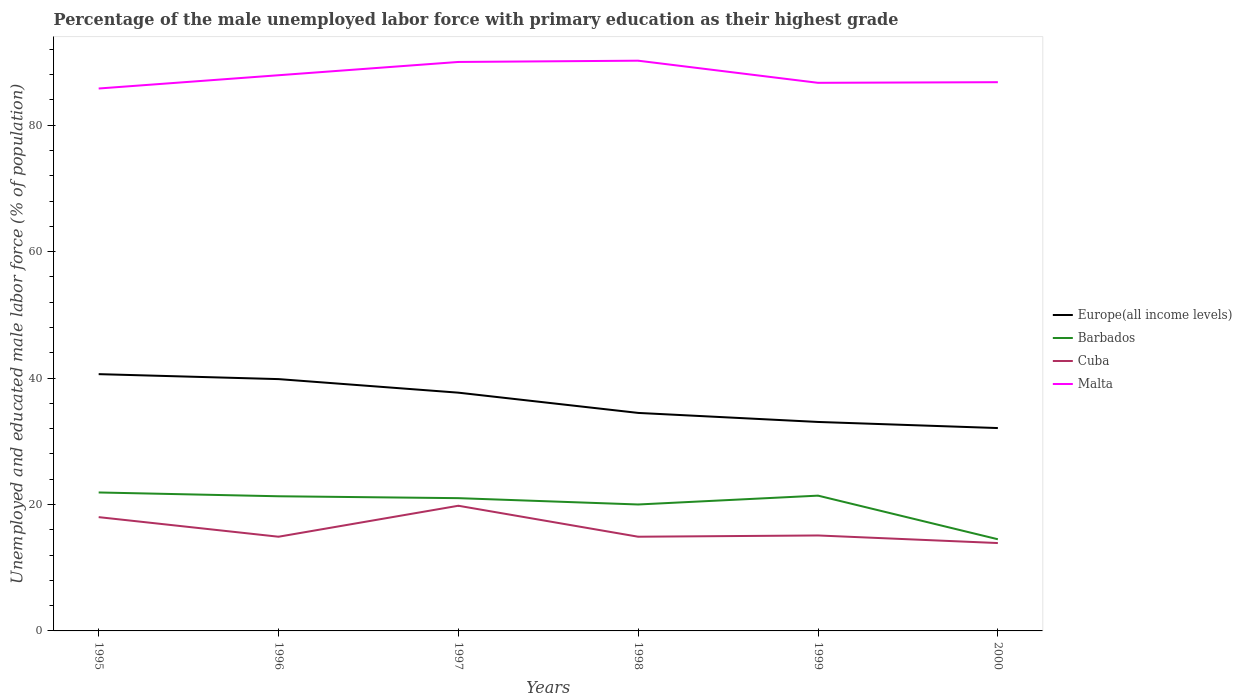How many different coloured lines are there?
Your response must be concise. 4. Is the number of lines equal to the number of legend labels?
Your response must be concise. Yes. Across all years, what is the maximum percentage of the unemployed male labor force with primary education in Cuba?
Your response must be concise. 13.9. In which year was the percentage of the unemployed male labor force with primary education in Europe(all income levels) maximum?
Offer a very short reply. 2000. What is the total percentage of the unemployed male labor force with primary education in Europe(all income levels) in the graph?
Provide a short and direct response. 4.63. What is the difference between the highest and the second highest percentage of the unemployed male labor force with primary education in Barbados?
Keep it short and to the point. 7.4. How many years are there in the graph?
Provide a short and direct response. 6. Are the values on the major ticks of Y-axis written in scientific E-notation?
Offer a terse response. No. Where does the legend appear in the graph?
Make the answer very short. Center right. How are the legend labels stacked?
Offer a very short reply. Vertical. What is the title of the graph?
Offer a terse response. Percentage of the male unemployed labor force with primary education as their highest grade. What is the label or title of the Y-axis?
Provide a short and direct response. Unemployed and educated male labor force (% of population). What is the Unemployed and educated male labor force (% of population) of Europe(all income levels) in 1995?
Keep it short and to the point. 40.62. What is the Unemployed and educated male labor force (% of population) of Barbados in 1995?
Offer a terse response. 21.9. What is the Unemployed and educated male labor force (% of population) in Malta in 1995?
Keep it short and to the point. 85.8. What is the Unemployed and educated male labor force (% of population) in Europe(all income levels) in 1996?
Keep it short and to the point. 39.83. What is the Unemployed and educated male labor force (% of population) in Barbados in 1996?
Offer a very short reply. 21.3. What is the Unemployed and educated male labor force (% of population) of Cuba in 1996?
Make the answer very short. 14.9. What is the Unemployed and educated male labor force (% of population) in Malta in 1996?
Your answer should be very brief. 87.9. What is the Unemployed and educated male labor force (% of population) of Europe(all income levels) in 1997?
Provide a succinct answer. 37.69. What is the Unemployed and educated male labor force (% of population) of Cuba in 1997?
Give a very brief answer. 19.8. What is the Unemployed and educated male labor force (% of population) in Malta in 1997?
Offer a terse response. 90. What is the Unemployed and educated male labor force (% of population) in Europe(all income levels) in 1998?
Provide a short and direct response. 34.48. What is the Unemployed and educated male labor force (% of population) in Barbados in 1998?
Keep it short and to the point. 20. What is the Unemployed and educated male labor force (% of population) in Cuba in 1998?
Offer a very short reply. 14.9. What is the Unemployed and educated male labor force (% of population) of Malta in 1998?
Keep it short and to the point. 90.2. What is the Unemployed and educated male labor force (% of population) in Europe(all income levels) in 1999?
Provide a succinct answer. 33.05. What is the Unemployed and educated male labor force (% of population) of Barbados in 1999?
Your answer should be compact. 21.4. What is the Unemployed and educated male labor force (% of population) in Cuba in 1999?
Your response must be concise. 15.1. What is the Unemployed and educated male labor force (% of population) in Malta in 1999?
Keep it short and to the point. 86.7. What is the Unemployed and educated male labor force (% of population) of Europe(all income levels) in 2000?
Make the answer very short. 32.09. What is the Unemployed and educated male labor force (% of population) in Barbados in 2000?
Keep it short and to the point. 14.5. What is the Unemployed and educated male labor force (% of population) of Cuba in 2000?
Your answer should be compact. 13.9. What is the Unemployed and educated male labor force (% of population) in Malta in 2000?
Provide a short and direct response. 86.8. Across all years, what is the maximum Unemployed and educated male labor force (% of population) in Europe(all income levels)?
Ensure brevity in your answer.  40.62. Across all years, what is the maximum Unemployed and educated male labor force (% of population) of Barbados?
Your response must be concise. 21.9. Across all years, what is the maximum Unemployed and educated male labor force (% of population) of Cuba?
Keep it short and to the point. 19.8. Across all years, what is the maximum Unemployed and educated male labor force (% of population) in Malta?
Ensure brevity in your answer.  90.2. Across all years, what is the minimum Unemployed and educated male labor force (% of population) of Europe(all income levels)?
Your answer should be compact. 32.09. Across all years, what is the minimum Unemployed and educated male labor force (% of population) of Barbados?
Offer a very short reply. 14.5. Across all years, what is the minimum Unemployed and educated male labor force (% of population) of Cuba?
Offer a terse response. 13.9. Across all years, what is the minimum Unemployed and educated male labor force (% of population) in Malta?
Ensure brevity in your answer.  85.8. What is the total Unemployed and educated male labor force (% of population) in Europe(all income levels) in the graph?
Offer a terse response. 217.77. What is the total Unemployed and educated male labor force (% of population) of Barbados in the graph?
Give a very brief answer. 120.1. What is the total Unemployed and educated male labor force (% of population) of Cuba in the graph?
Provide a short and direct response. 96.6. What is the total Unemployed and educated male labor force (% of population) of Malta in the graph?
Your answer should be compact. 527.4. What is the difference between the Unemployed and educated male labor force (% of population) in Europe(all income levels) in 1995 and that in 1996?
Ensure brevity in your answer.  0.78. What is the difference between the Unemployed and educated male labor force (% of population) of Barbados in 1995 and that in 1996?
Your response must be concise. 0.6. What is the difference between the Unemployed and educated male labor force (% of population) in Malta in 1995 and that in 1996?
Your answer should be compact. -2.1. What is the difference between the Unemployed and educated male labor force (% of population) of Europe(all income levels) in 1995 and that in 1997?
Provide a short and direct response. 2.93. What is the difference between the Unemployed and educated male labor force (% of population) of Barbados in 1995 and that in 1997?
Your answer should be compact. 0.9. What is the difference between the Unemployed and educated male labor force (% of population) in Cuba in 1995 and that in 1997?
Your answer should be compact. -1.8. What is the difference between the Unemployed and educated male labor force (% of population) of Europe(all income levels) in 1995 and that in 1998?
Keep it short and to the point. 6.13. What is the difference between the Unemployed and educated male labor force (% of population) of Barbados in 1995 and that in 1998?
Your answer should be compact. 1.9. What is the difference between the Unemployed and educated male labor force (% of population) of Europe(all income levels) in 1995 and that in 1999?
Ensure brevity in your answer.  7.56. What is the difference between the Unemployed and educated male labor force (% of population) of Barbados in 1995 and that in 1999?
Offer a terse response. 0.5. What is the difference between the Unemployed and educated male labor force (% of population) of Cuba in 1995 and that in 1999?
Provide a short and direct response. 2.9. What is the difference between the Unemployed and educated male labor force (% of population) of Malta in 1995 and that in 1999?
Your response must be concise. -0.9. What is the difference between the Unemployed and educated male labor force (% of population) of Europe(all income levels) in 1995 and that in 2000?
Provide a short and direct response. 8.53. What is the difference between the Unemployed and educated male labor force (% of population) of Cuba in 1995 and that in 2000?
Your answer should be compact. 4.1. What is the difference between the Unemployed and educated male labor force (% of population) of Europe(all income levels) in 1996 and that in 1997?
Your answer should be compact. 2.14. What is the difference between the Unemployed and educated male labor force (% of population) of Europe(all income levels) in 1996 and that in 1998?
Ensure brevity in your answer.  5.35. What is the difference between the Unemployed and educated male labor force (% of population) of Cuba in 1996 and that in 1998?
Ensure brevity in your answer.  0. What is the difference between the Unemployed and educated male labor force (% of population) of Malta in 1996 and that in 1998?
Your response must be concise. -2.3. What is the difference between the Unemployed and educated male labor force (% of population) in Europe(all income levels) in 1996 and that in 1999?
Give a very brief answer. 6.78. What is the difference between the Unemployed and educated male labor force (% of population) of Barbados in 1996 and that in 1999?
Your response must be concise. -0.1. What is the difference between the Unemployed and educated male labor force (% of population) in Europe(all income levels) in 1996 and that in 2000?
Make the answer very short. 7.74. What is the difference between the Unemployed and educated male labor force (% of population) of Cuba in 1996 and that in 2000?
Provide a short and direct response. 1. What is the difference between the Unemployed and educated male labor force (% of population) in Malta in 1996 and that in 2000?
Offer a terse response. 1.1. What is the difference between the Unemployed and educated male labor force (% of population) of Europe(all income levels) in 1997 and that in 1998?
Your answer should be very brief. 3.2. What is the difference between the Unemployed and educated male labor force (% of population) of Europe(all income levels) in 1997 and that in 1999?
Offer a very short reply. 4.63. What is the difference between the Unemployed and educated male labor force (% of population) of Cuba in 1997 and that in 1999?
Offer a terse response. 4.7. What is the difference between the Unemployed and educated male labor force (% of population) of Europe(all income levels) in 1997 and that in 2000?
Make the answer very short. 5.6. What is the difference between the Unemployed and educated male labor force (% of population) of Barbados in 1997 and that in 2000?
Your response must be concise. 6.5. What is the difference between the Unemployed and educated male labor force (% of population) in Cuba in 1997 and that in 2000?
Your answer should be compact. 5.9. What is the difference between the Unemployed and educated male labor force (% of population) in Malta in 1997 and that in 2000?
Give a very brief answer. 3.2. What is the difference between the Unemployed and educated male labor force (% of population) in Europe(all income levels) in 1998 and that in 1999?
Your answer should be compact. 1.43. What is the difference between the Unemployed and educated male labor force (% of population) in Cuba in 1998 and that in 1999?
Offer a terse response. -0.2. What is the difference between the Unemployed and educated male labor force (% of population) of Europe(all income levels) in 1998 and that in 2000?
Your response must be concise. 2.4. What is the difference between the Unemployed and educated male labor force (% of population) in Malta in 1998 and that in 2000?
Offer a terse response. 3.4. What is the difference between the Unemployed and educated male labor force (% of population) in Europe(all income levels) in 1999 and that in 2000?
Your response must be concise. 0.97. What is the difference between the Unemployed and educated male labor force (% of population) of Cuba in 1999 and that in 2000?
Your answer should be compact. 1.2. What is the difference between the Unemployed and educated male labor force (% of population) of Malta in 1999 and that in 2000?
Provide a succinct answer. -0.1. What is the difference between the Unemployed and educated male labor force (% of population) in Europe(all income levels) in 1995 and the Unemployed and educated male labor force (% of population) in Barbados in 1996?
Make the answer very short. 19.32. What is the difference between the Unemployed and educated male labor force (% of population) in Europe(all income levels) in 1995 and the Unemployed and educated male labor force (% of population) in Cuba in 1996?
Your answer should be very brief. 25.72. What is the difference between the Unemployed and educated male labor force (% of population) of Europe(all income levels) in 1995 and the Unemployed and educated male labor force (% of population) of Malta in 1996?
Ensure brevity in your answer.  -47.28. What is the difference between the Unemployed and educated male labor force (% of population) of Barbados in 1995 and the Unemployed and educated male labor force (% of population) of Cuba in 1996?
Give a very brief answer. 7. What is the difference between the Unemployed and educated male labor force (% of population) of Barbados in 1995 and the Unemployed and educated male labor force (% of population) of Malta in 1996?
Your response must be concise. -66. What is the difference between the Unemployed and educated male labor force (% of population) in Cuba in 1995 and the Unemployed and educated male labor force (% of population) in Malta in 1996?
Keep it short and to the point. -69.9. What is the difference between the Unemployed and educated male labor force (% of population) in Europe(all income levels) in 1995 and the Unemployed and educated male labor force (% of population) in Barbados in 1997?
Ensure brevity in your answer.  19.62. What is the difference between the Unemployed and educated male labor force (% of population) of Europe(all income levels) in 1995 and the Unemployed and educated male labor force (% of population) of Cuba in 1997?
Ensure brevity in your answer.  20.82. What is the difference between the Unemployed and educated male labor force (% of population) in Europe(all income levels) in 1995 and the Unemployed and educated male labor force (% of population) in Malta in 1997?
Your response must be concise. -49.38. What is the difference between the Unemployed and educated male labor force (% of population) in Barbados in 1995 and the Unemployed and educated male labor force (% of population) in Malta in 1997?
Offer a very short reply. -68.1. What is the difference between the Unemployed and educated male labor force (% of population) of Cuba in 1995 and the Unemployed and educated male labor force (% of population) of Malta in 1997?
Make the answer very short. -72. What is the difference between the Unemployed and educated male labor force (% of population) of Europe(all income levels) in 1995 and the Unemployed and educated male labor force (% of population) of Barbados in 1998?
Give a very brief answer. 20.62. What is the difference between the Unemployed and educated male labor force (% of population) in Europe(all income levels) in 1995 and the Unemployed and educated male labor force (% of population) in Cuba in 1998?
Keep it short and to the point. 25.72. What is the difference between the Unemployed and educated male labor force (% of population) in Europe(all income levels) in 1995 and the Unemployed and educated male labor force (% of population) in Malta in 1998?
Make the answer very short. -49.58. What is the difference between the Unemployed and educated male labor force (% of population) in Barbados in 1995 and the Unemployed and educated male labor force (% of population) in Cuba in 1998?
Provide a short and direct response. 7. What is the difference between the Unemployed and educated male labor force (% of population) of Barbados in 1995 and the Unemployed and educated male labor force (% of population) of Malta in 1998?
Provide a succinct answer. -68.3. What is the difference between the Unemployed and educated male labor force (% of population) of Cuba in 1995 and the Unemployed and educated male labor force (% of population) of Malta in 1998?
Your answer should be very brief. -72.2. What is the difference between the Unemployed and educated male labor force (% of population) of Europe(all income levels) in 1995 and the Unemployed and educated male labor force (% of population) of Barbados in 1999?
Give a very brief answer. 19.22. What is the difference between the Unemployed and educated male labor force (% of population) of Europe(all income levels) in 1995 and the Unemployed and educated male labor force (% of population) of Cuba in 1999?
Offer a terse response. 25.52. What is the difference between the Unemployed and educated male labor force (% of population) of Europe(all income levels) in 1995 and the Unemployed and educated male labor force (% of population) of Malta in 1999?
Offer a very short reply. -46.08. What is the difference between the Unemployed and educated male labor force (% of population) of Barbados in 1995 and the Unemployed and educated male labor force (% of population) of Malta in 1999?
Your answer should be very brief. -64.8. What is the difference between the Unemployed and educated male labor force (% of population) of Cuba in 1995 and the Unemployed and educated male labor force (% of population) of Malta in 1999?
Offer a terse response. -68.7. What is the difference between the Unemployed and educated male labor force (% of population) in Europe(all income levels) in 1995 and the Unemployed and educated male labor force (% of population) in Barbados in 2000?
Keep it short and to the point. 26.12. What is the difference between the Unemployed and educated male labor force (% of population) of Europe(all income levels) in 1995 and the Unemployed and educated male labor force (% of population) of Cuba in 2000?
Your answer should be compact. 26.72. What is the difference between the Unemployed and educated male labor force (% of population) in Europe(all income levels) in 1995 and the Unemployed and educated male labor force (% of population) in Malta in 2000?
Your answer should be compact. -46.18. What is the difference between the Unemployed and educated male labor force (% of population) of Barbados in 1995 and the Unemployed and educated male labor force (% of population) of Malta in 2000?
Give a very brief answer. -64.9. What is the difference between the Unemployed and educated male labor force (% of population) in Cuba in 1995 and the Unemployed and educated male labor force (% of population) in Malta in 2000?
Your response must be concise. -68.8. What is the difference between the Unemployed and educated male labor force (% of population) in Europe(all income levels) in 1996 and the Unemployed and educated male labor force (% of population) in Barbados in 1997?
Your response must be concise. 18.83. What is the difference between the Unemployed and educated male labor force (% of population) in Europe(all income levels) in 1996 and the Unemployed and educated male labor force (% of population) in Cuba in 1997?
Keep it short and to the point. 20.03. What is the difference between the Unemployed and educated male labor force (% of population) of Europe(all income levels) in 1996 and the Unemployed and educated male labor force (% of population) of Malta in 1997?
Ensure brevity in your answer.  -50.17. What is the difference between the Unemployed and educated male labor force (% of population) in Barbados in 1996 and the Unemployed and educated male labor force (% of population) in Cuba in 1997?
Provide a short and direct response. 1.5. What is the difference between the Unemployed and educated male labor force (% of population) of Barbados in 1996 and the Unemployed and educated male labor force (% of population) of Malta in 1997?
Offer a terse response. -68.7. What is the difference between the Unemployed and educated male labor force (% of population) in Cuba in 1996 and the Unemployed and educated male labor force (% of population) in Malta in 1997?
Offer a terse response. -75.1. What is the difference between the Unemployed and educated male labor force (% of population) in Europe(all income levels) in 1996 and the Unemployed and educated male labor force (% of population) in Barbados in 1998?
Offer a terse response. 19.83. What is the difference between the Unemployed and educated male labor force (% of population) of Europe(all income levels) in 1996 and the Unemployed and educated male labor force (% of population) of Cuba in 1998?
Provide a short and direct response. 24.93. What is the difference between the Unemployed and educated male labor force (% of population) of Europe(all income levels) in 1996 and the Unemployed and educated male labor force (% of population) of Malta in 1998?
Provide a short and direct response. -50.37. What is the difference between the Unemployed and educated male labor force (% of population) of Barbados in 1996 and the Unemployed and educated male labor force (% of population) of Malta in 1998?
Offer a very short reply. -68.9. What is the difference between the Unemployed and educated male labor force (% of population) in Cuba in 1996 and the Unemployed and educated male labor force (% of population) in Malta in 1998?
Ensure brevity in your answer.  -75.3. What is the difference between the Unemployed and educated male labor force (% of population) of Europe(all income levels) in 1996 and the Unemployed and educated male labor force (% of population) of Barbados in 1999?
Your answer should be compact. 18.43. What is the difference between the Unemployed and educated male labor force (% of population) of Europe(all income levels) in 1996 and the Unemployed and educated male labor force (% of population) of Cuba in 1999?
Ensure brevity in your answer.  24.73. What is the difference between the Unemployed and educated male labor force (% of population) of Europe(all income levels) in 1996 and the Unemployed and educated male labor force (% of population) of Malta in 1999?
Provide a succinct answer. -46.87. What is the difference between the Unemployed and educated male labor force (% of population) in Barbados in 1996 and the Unemployed and educated male labor force (% of population) in Malta in 1999?
Ensure brevity in your answer.  -65.4. What is the difference between the Unemployed and educated male labor force (% of population) in Cuba in 1996 and the Unemployed and educated male labor force (% of population) in Malta in 1999?
Give a very brief answer. -71.8. What is the difference between the Unemployed and educated male labor force (% of population) in Europe(all income levels) in 1996 and the Unemployed and educated male labor force (% of population) in Barbados in 2000?
Offer a terse response. 25.33. What is the difference between the Unemployed and educated male labor force (% of population) of Europe(all income levels) in 1996 and the Unemployed and educated male labor force (% of population) of Cuba in 2000?
Provide a short and direct response. 25.93. What is the difference between the Unemployed and educated male labor force (% of population) in Europe(all income levels) in 1996 and the Unemployed and educated male labor force (% of population) in Malta in 2000?
Ensure brevity in your answer.  -46.97. What is the difference between the Unemployed and educated male labor force (% of population) of Barbados in 1996 and the Unemployed and educated male labor force (% of population) of Malta in 2000?
Offer a very short reply. -65.5. What is the difference between the Unemployed and educated male labor force (% of population) of Cuba in 1996 and the Unemployed and educated male labor force (% of population) of Malta in 2000?
Provide a succinct answer. -71.9. What is the difference between the Unemployed and educated male labor force (% of population) in Europe(all income levels) in 1997 and the Unemployed and educated male labor force (% of population) in Barbados in 1998?
Your answer should be very brief. 17.69. What is the difference between the Unemployed and educated male labor force (% of population) of Europe(all income levels) in 1997 and the Unemployed and educated male labor force (% of population) of Cuba in 1998?
Offer a very short reply. 22.79. What is the difference between the Unemployed and educated male labor force (% of population) of Europe(all income levels) in 1997 and the Unemployed and educated male labor force (% of population) of Malta in 1998?
Give a very brief answer. -52.51. What is the difference between the Unemployed and educated male labor force (% of population) in Barbados in 1997 and the Unemployed and educated male labor force (% of population) in Cuba in 1998?
Offer a very short reply. 6.1. What is the difference between the Unemployed and educated male labor force (% of population) of Barbados in 1997 and the Unemployed and educated male labor force (% of population) of Malta in 1998?
Offer a very short reply. -69.2. What is the difference between the Unemployed and educated male labor force (% of population) of Cuba in 1997 and the Unemployed and educated male labor force (% of population) of Malta in 1998?
Keep it short and to the point. -70.4. What is the difference between the Unemployed and educated male labor force (% of population) in Europe(all income levels) in 1997 and the Unemployed and educated male labor force (% of population) in Barbados in 1999?
Your answer should be compact. 16.29. What is the difference between the Unemployed and educated male labor force (% of population) in Europe(all income levels) in 1997 and the Unemployed and educated male labor force (% of population) in Cuba in 1999?
Provide a short and direct response. 22.59. What is the difference between the Unemployed and educated male labor force (% of population) of Europe(all income levels) in 1997 and the Unemployed and educated male labor force (% of population) of Malta in 1999?
Keep it short and to the point. -49.01. What is the difference between the Unemployed and educated male labor force (% of population) of Barbados in 1997 and the Unemployed and educated male labor force (% of population) of Malta in 1999?
Provide a short and direct response. -65.7. What is the difference between the Unemployed and educated male labor force (% of population) in Cuba in 1997 and the Unemployed and educated male labor force (% of population) in Malta in 1999?
Your answer should be compact. -66.9. What is the difference between the Unemployed and educated male labor force (% of population) of Europe(all income levels) in 1997 and the Unemployed and educated male labor force (% of population) of Barbados in 2000?
Provide a succinct answer. 23.19. What is the difference between the Unemployed and educated male labor force (% of population) of Europe(all income levels) in 1997 and the Unemployed and educated male labor force (% of population) of Cuba in 2000?
Your answer should be very brief. 23.79. What is the difference between the Unemployed and educated male labor force (% of population) of Europe(all income levels) in 1997 and the Unemployed and educated male labor force (% of population) of Malta in 2000?
Your answer should be compact. -49.11. What is the difference between the Unemployed and educated male labor force (% of population) in Barbados in 1997 and the Unemployed and educated male labor force (% of population) in Cuba in 2000?
Provide a short and direct response. 7.1. What is the difference between the Unemployed and educated male labor force (% of population) of Barbados in 1997 and the Unemployed and educated male labor force (% of population) of Malta in 2000?
Your response must be concise. -65.8. What is the difference between the Unemployed and educated male labor force (% of population) in Cuba in 1997 and the Unemployed and educated male labor force (% of population) in Malta in 2000?
Ensure brevity in your answer.  -67. What is the difference between the Unemployed and educated male labor force (% of population) in Europe(all income levels) in 1998 and the Unemployed and educated male labor force (% of population) in Barbados in 1999?
Provide a succinct answer. 13.08. What is the difference between the Unemployed and educated male labor force (% of population) in Europe(all income levels) in 1998 and the Unemployed and educated male labor force (% of population) in Cuba in 1999?
Keep it short and to the point. 19.38. What is the difference between the Unemployed and educated male labor force (% of population) of Europe(all income levels) in 1998 and the Unemployed and educated male labor force (% of population) of Malta in 1999?
Provide a short and direct response. -52.22. What is the difference between the Unemployed and educated male labor force (% of population) of Barbados in 1998 and the Unemployed and educated male labor force (% of population) of Malta in 1999?
Your answer should be compact. -66.7. What is the difference between the Unemployed and educated male labor force (% of population) in Cuba in 1998 and the Unemployed and educated male labor force (% of population) in Malta in 1999?
Give a very brief answer. -71.8. What is the difference between the Unemployed and educated male labor force (% of population) of Europe(all income levels) in 1998 and the Unemployed and educated male labor force (% of population) of Barbados in 2000?
Ensure brevity in your answer.  19.98. What is the difference between the Unemployed and educated male labor force (% of population) of Europe(all income levels) in 1998 and the Unemployed and educated male labor force (% of population) of Cuba in 2000?
Provide a succinct answer. 20.58. What is the difference between the Unemployed and educated male labor force (% of population) in Europe(all income levels) in 1998 and the Unemployed and educated male labor force (% of population) in Malta in 2000?
Provide a succinct answer. -52.32. What is the difference between the Unemployed and educated male labor force (% of population) in Barbados in 1998 and the Unemployed and educated male labor force (% of population) in Cuba in 2000?
Provide a short and direct response. 6.1. What is the difference between the Unemployed and educated male labor force (% of population) of Barbados in 1998 and the Unemployed and educated male labor force (% of population) of Malta in 2000?
Give a very brief answer. -66.8. What is the difference between the Unemployed and educated male labor force (% of population) in Cuba in 1998 and the Unemployed and educated male labor force (% of population) in Malta in 2000?
Your answer should be compact. -71.9. What is the difference between the Unemployed and educated male labor force (% of population) of Europe(all income levels) in 1999 and the Unemployed and educated male labor force (% of population) of Barbados in 2000?
Ensure brevity in your answer.  18.55. What is the difference between the Unemployed and educated male labor force (% of population) of Europe(all income levels) in 1999 and the Unemployed and educated male labor force (% of population) of Cuba in 2000?
Give a very brief answer. 19.15. What is the difference between the Unemployed and educated male labor force (% of population) of Europe(all income levels) in 1999 and the Unemployed and educated male labor force (% of population) of Malta in 2000?
Give a very brief answer. -53.75. What is the difference between the Unemployed and educated male labor force (% of population) of Barbados in 1999 and the Unemployed and educated male labor force (% of population) of Malta in 2000?
Ensure brevity in your answer.  -65.4. What is the difference between the Unemployed and educated male labor force (% of population) in Cuba in 1999 and the Unemployed and educated male labor force (% of population) in Malta in 2000?
Your response must be concise. -71.7. What is the average Unemployed and educated male labor force (% of population) in Europe(all income levels) per year?
Provide a short and direct response. 36.29. What is the average Unemployed and educated male labor force (% of population) of Barbados per year?
Give a very brief answer. 20.02. What is the average Unemployed and educated male labor force (% of population) in Cuba per year?
Your response must be concise. 16.1. What is the average Unemployed and educated male labor force (% of population) in Malta per year?
Offer a very short reply. 87.9. In the year 1995, what is the difference between the Unemployed and educated male labor force (% of population) of Europe(all income levels) and Unemployed and educated male labor force (% of population) of Barbados?
Your answer should be very brief. 18.72. In the year 1995, what is the difference between the Unemployed and educated male labor force (% of population) of Europe(all income levels) and Unemployed and educated male labor force (% of population) of Cuba?
Offer a very short reply. 22.62. In the year 1995, what is the difference between the Unemployed and educated male labor force (% of population) in Europe(all income levels) and Unemployed and educated male labor force (% of population) in Malta?
Give a very brief answer. -45.18. In the year 1995, what is the difference between the Unemployed and educated male labor force (% of population) in Barbados and Unemployed and educated male labor force (% of population) in Malta?
Provide a short and direct response. -63.9. In the year 1995, what is the difference between the Unemployed and educated male labor force (% of population) in Cuba and Unemployed and educated male labor force (% of population) in Malta?
Make the answer very short. -67.8. In the year 1996, what is the difference between the Unemployed and educated male labor force (% of population) in Europe(all income levels) and Unemployed and educated male labor force (% of population) in Barbados?
Offer a terse response. 18.53. In the year 1996, what is the difference between the Unemployed and educated male labor force (% of population) in Europe(all income levels) and Unemployed and educated male labor force (% of population) in Cuba?
Keep it short and to the point. 24.93. In the year 1996, what is the difference between the Unemployed and educated male labor force (% of population) in Europe(all income levels) and Unemployed and educated male labor force (% of population) in Malta?
Offer a terse response. -48.07. In the year 1996, what is the difference between the Unemployed and educated male labor force (% of population) of Barbados and Unemployed and educated male labor force (% of population) of Cuba?
Your answer should be compact. 6.4. In the year 1996, what is the difference between the Unemployed and educated male labor force (% of population) in Barbados and Unemployed and educated male labor force (% of population) in Malta?
Provide a succinct answer. -66.6. In the year 1996, what is the difference between the Unemployed and educated male labor force (% of population) of Cuba and Unemployed and educated male labor force (% of population) of Malta?
Make the answer very short. -73. In the year 1997, what is the difference between the Unemployed and educated male labor force (% of population) in Europe(all income levels) and Unemployed and educated male labor force (% of population) in Barbados?
Your answer should be compact. 16.69. In the year 1997, what is the difference between the Unemployed and educated male labor force (% of population) in Europe(all income levels) and Unemployed and educated male labor force (% of population) in Cuba?
Make the answer very short. 17.89. In the year 1997, what is the difference between the Unemployed and educated male labor force (% of population) of Europe(all income levels) and Unemployed and educated male labor force (% of population) of Malta?
Offer a terse response. -52.31. In the year 1997, what is the difference between the Unemployed and educated male labor force (% of population) of Barbados and Unemployed and educated male labor force (% of population) of Malta?
Your response must be concise. -69. In the year 1997, what is the difference between the Unemployed and educated male labor force (% of population) of Cuba and Unemployed and educated male labor force (% of population) of Malta?
Offer a very short reply. -70.2. In the year 1998, what is the difference between the Unemployed and educated male labor force (% of population) in Europe(all income levels) and Unemployed and educated male labor force (% of population) in Barbados?
Offer a very short reply. 14.48. In the year 1998, what is the difference between the Unemployed and educated male labor force (% of population) of Europe(all income levels) and Unemployed and educated male labor force (% of population) of Cuba?
Keep it short and to the point. 19.58. In the year 1998, what is the difference between the Unemployed and educated male labor force (% of population) in Europe(all income levels) and Unemployed and educated male labor force (% of population) in Malta?
Keep it short and to the point. -55.72. In the year 1998, what is the difference between the Unemployed and educated male labor force (% of population) of Barbados and Unemployed and educated male labor force (% of population) of Malta?
Your answer should be very brief. -70.2. In the year 1998, what is the difference between the Unemployed and educated male labor force (% of population) of Cuba and Unemployed and educated male labor force (% of population) of Malta?
Offer a very short reply. -75.3. In the year 1999, what is the difference between the Unemployed and educated male labor force (% of population) of Europe(all income levels) and Unemployed and educated male labor force (% of population) of Barbados?
Offer a very short reply. 11.65. In the year 1999, what is the difference between the Unemployed and educated male labor force (% of population) in Europe(all income levels) and Unemployed and educated male labor force (% of population) in Cuba?
Make the answer very short. 17.95. In the year 1999, what is the difference between the Unemployed and educated male labor force (% of population) in Europe(all income levels) and Unemployed and educated male labor force (% of population) in Malta?
Your answer should be very brief. -53.65. In the year 1999, what is the difference between the Unemployed and educated male labor force (% of population) of Barbados and Unemployed and educated male labor force (% of population) of Malta?
Keep it short and to the point. -65.3. In the year 1999, what is the difference between the Unemployed and educated male labor force (% of population) of Cuba and Unemployed and educated male labor force (% of population) of Malta?
Keep it short and to the point. -71.6. In the year 2000, what is the difference between the Unemployed and educated male labor force (% of population) in Europe(all income levels) and Unemployed and educated male labor force (% of population) in Barbados?
Ensure brevity in your answer.  17.59. In the year 2000, what is the difference between the Unemployed and educated male labor force (% of population) in Europe(all income levels) and Unemployed and educated male labor force (% of population) in Cuba?
Ensure brevity in your answer.  18.19. In the year 2000, what is the difference between the Unemployed and educated male labor force (% of population) in Europe(all income levels) and Unemployed and educated male labor force (% of population) in Malta?
Your answer should be compact. -54.71. In the year 2000, what is the difference between the Unemployed and educated male labor force (% of population) in Barbados and Unemployed and educated male labor force (% of population) in Malta?
Offer a very short reply. -72.3. In the year 2000, what is the difference between the Unemployed and educated male labor force (% of population) in Cuba and Unemployed and educated male labor force (% of population) in Malta?
Keep it short and to the point. -72.9. What is the ratio of the Unemployed and educated male labor force (% of population) of Europe(all income levels) in 1995 to that in 1996?
Give a very brief answer. 1.02. What is the ratio of the Unemployed and educated male labor force (% of population) of Barbados in 1995 to that in 1996?
Ensure brevity in your answer.  1.03. What is the ratio of the Unemployed and educated male labor force (% of population) of Cuba in 1995 to that in 1996?
Give a very brief answer. 1.21. What is the ratio of the Unemployed and educated male labor force (% of population) in Malta in 1995 to that in 1996?
Offer a terse response. 0.98. What is the ratio of the Unemployed and educated male labor force (% of population) of Europe(all income levels) in 1995 to that in 1997?
Make the answer very short. 1.08. What is the ratio of the Unemployed and educated male labor force (% of population) of Barbados in 1995 to that in 1997?
Make the answer very short. 1.04. What is the ratio of the Unemployed and educated male labor force (% of population) in Cuba in 1995 to that in 1997?
Offer a very short reply. 0.91. What is the ratio of the Unemployed and educated male labor force (% of population) in Malta in 1995 to that in 1997?
Your answer should be compact. 0.95. What is the ratio of the Unemployed and educated male labor force (% of population) of Europe(all income levels) in 1995 to that in 1998?
Your answer should be compact. 1.18. What is the ratio of the Unemployed and educated male labor force (% of population) of Barbados in 1995 to that in 1998?
Your answer should be compact. 1.09. What is the ratio of the Unemployed and educated male labor force (% of population) in Cuba in 1995 to that in 1998?
Offer a terse response. 1.21. What is the ratio of the Unemployed and educated male labor force (% of population) in Malta in 1995 to that in 1998?
Provide a succinct answer. 0.95. What is the ratio of the Unemployed and educated male labor force (% of population) in Europe(all income levels) in 1995 to that in 1999?
Provide a succinct answer. 1.23. What is the ratio of the Unemployed and educated male labor force (% of population) of Barbados in 1995 to that in 1999?
Ensure brevity in your answer.  1.02. What is the ratio of the Unemployed and educated male labor force (% of population) in Cuba in 1995 to that in 1999?
Provide a short and direct response. 1.19. What is the ratio of the Unemployed and educated male labor force (% of population) of Europe(all income levels) in 1995 to that in 2000?
Your answer should be compact. 1.27. What is the ratio of the Unemployed and educated male labor force (% of population) of Barbados in 1995 to that in 2000?
Keep it short and to the point. 1.51. What is the ratio of the Unemployed and educated male labor force (% of population) in Cuba in 1995 to that in 2000?
Offer a terse response. 1.29. What is the ratio of the Unemployed and educated male labor force (% of population) of Malta in 1995 to that in 2000?
Give a very brief answer. 0.99. What is the ratio of the Unemployed and educated male labor force (% of population) of Europe(all income levels) in 1996 to that in 1997?
Ensure brevity in your answer.  1.06. What is the ratio of the Unemployed and educated male labor force (% of population) in Barbados in 1996 to that in 1997?
Keep it short and to the point. 1.01. What is the ratio of the Unemployed and educated male labor force (% of population) in Cuba in 1996 to that in 1997?
Give a very brief answer. 0.75. What is the ratio of the Unemployed and educated male labor force (% of population) of Malta in 1996 to that in 1997?
Your answer should be very brief. 0.98. What is the ratio of the Unemployed and educated male labor force (% of population) of Europe(all income levels) in 1996 to that in 1998?
Your response must be concise. 1.16. What is the ratio of the Unemployed and educated male labor force (% of population) of Barbados in 1996 to that in 1998?
Make the answer very short. 1.06. What is the ratio of the Unemployed and educated male labor force (% of population) in Cuba in 1996 to that in 1998?
Give a very brief answer. 1. What is the ratio of the Unemployed and educated male labor force (% of population) in Malta in 1996 to that in 1998?
Provide a succinct answer. 0.97. What is the ratio of the Unemployed and educated male labor force (% of population) in Europe(all income levels) in 1996 to that in 1999?
Your answer should be very brief. 1.21. What is the ratio of the Unemployed and educated male labor force (% of population) of Malta in 1996 to that in 1999?
Offer a very short reply. 1.01. What is the ratio of the Unemployed and educated male labor force (% of population) of Europe(all income levels) in 1996 to that in 2000?
Keep it short and to the point. 1.24. What is the ratio of the Unemployed and educated male labor force (% of population) in Barbados in 1996 to that in 2000?
Keep it short and to the point. 1.47. What is the ratio of the Unemployed and educated male labor force (% of population) in Cuba in 1996 to that in 2000?
Keep it short and to the point. 1.07. What is the ratio of the Unemployed and educated male labor force (% of population) in Malta in 1996 to that in 2000?
Your answer should be compact. 1.01. What is the ratio of the Unemployed and educated male labor force (% of population) in Europe(all income levels) in 1997 to that in 1998?
Your answer should be very brief. 1.09. What is the ratio of the Unemployed and educated male labor force (% of population) in Barbados in 1997 to that in 1998?
Offer a terse response. 1.05. What is the ratio of the Unemployed and educated male labor force (% of population) of Cuba in 1997 to that in 1998?
Keep it short and to the point. 1.33. What is the ratio of the Unemployed and educated male labor force (% of population) of Europe(all income levels) in 1997 to that in 1999?
Keep it short and to the point. 1.14. What is the ratio of the Unemployed and educated male labor force (% of population) of Barbados in 1997 to that in 1999?
Provide a succinct answer. 0.98. What is the ratio of the Unemployed and educated male labor force (% of population) in Cuba in 1997 to that in 1999?
Keep it short and to the point. 1.31. What is the ratio of the Unemployed and educated male labor force (% of population) in Malta in 1997 to that in 1999?
Ensure brevity in your answer.  1.04. What is the ratio of the Unemployed and educated male labor force (% of population) of Europe(all income levels) in 1997 to that in 2000?
Your response must be concise. 1.17. What is the ratio of the Unemployed and educated male labor force (% of population) of Barbados in 1997 to that in 2000?
Make the answer very short. 1.45. What is the ratio of the Unemployed and educated male labor force (% of population) in Cuba in 1997 to that in 2000?
Make the answer very short. 1.42. What is the ratio of the Unemployed and educated male labor force (% of population) in Malta in 1997 to that in 2000?
Keep it short and to the point. 1.04. What is the ratio of the Unemployed and educated male labor force (% of population) in Europe(all income levels) in 1998 to that in 1999?
Offer a terse response. 1.04. What is the ratio of the Unemployed and educated male labor force (% of population) of Barbados in 1998 to that in 1999?
Your answer should be very brief. 0.93. What is the ratio of the Unemployed and educated male labor force (% of population) of Malta in 1998 to that in 1999?
Offer a terse response. 1.04. What is the ratio of the Unemployed and educated male labor force (% of population) of Europe(all income levels) in 1998 to that in 2000?
Ensure brevity in your answer.  1.07. What is the ratio of the Unemployed and educated male labor force (% of population) in Barbados in 1998 to that in 2000?
Provide a short and direct response. 1.38. What is the ratio of the Unemployed and educated male labor force (% of population) in Cuba in 1998 to that in 2000?
Offer a terse response. 1.07. What is the ratio of the Unemployed and educated male labor force (% of population) in Malta in 1998 to that in 2000?
Offer a very short reply. 1.04. What is the ratio of the Unemployed and educated male labor force (% of population) in Europe(all income levels) in 1999 to that in 2000?
Offer a very short reply. 1.03. What is the ratio of the Unemployed and educated male labor force (% of population) of Barbados in 1999 to that in 2000?
Your answer should be compact. 1.48. What is the ratio of the Unemployed and educated male labor force (% of population) of Cuba in 1999 to that in 2000?
Offer a very short reply. 1.09. What is the ratio of the Unemployed and educated male labor force (% of population) of Malta in 1999 to that in 2000?
Your answer should be compact. 1. What is the difference between the highest and the second highest Unemployed and educated male labor force (% of population) in Europe(all income levels)?
Provide a succinct answer. 0.78. What is the difference between the highest and the second highest Unemployed and educated male labor force (% of population) of Malta?
Make the answer very short. 0.2. What is the difference between the highest and the lowest Unemployed and educated male labor force (% of population) of Europe(all income levels)?
Provide a short and direct response. 8.53. What is the difference between the highest and the lowest Unemployed and educated male labor force (% of population) in Barbados?
Offer a very short reply. 7.4. What is the difference between the highest and the lowest Unemployed and educated male labor force (% of population) in Cuba?
Your response must be concise. 5.9. 